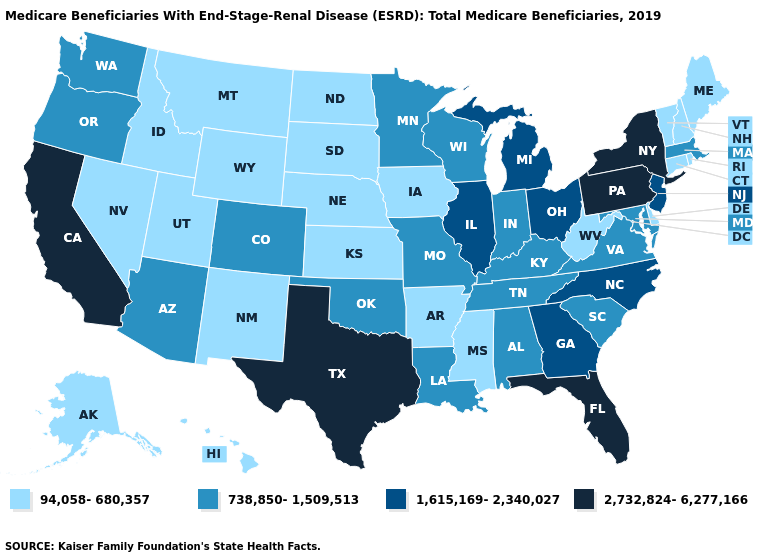Name the states that have a value in the range 94,058-680,357?
Answer briefly. Alaska, Arkansas, Connecticut, Delaware, Hawaii, Idaho, Iowa, Kansas, Maine, Mississippi, Montana, Nebraska, Nevada, New Hampshire, New Mexico, North Dakota, Rhode Island, South Dakota, Utah, Vermont, West Virginia, Wyoming. What is the value of Oklahoma?
Short answer required. 738,850-1,509,513. What is the value of Nebraska?
Answer briefly. 94,058-680,357. How many symbols are there in the legend?
Short answer required. 4. Name the states that have a value in the range 2,732,824-6,277,166?
Quick response, please. California, Florida, New York, Pennsylvania, Texas. Name the states that have a value in the range 94,058-680,357?
Write a very short answer. Alaska, Arkansas, Connecticut, Delaware, Hawaii, Idaho, Iowa, Kansas, Maine, Mississippi, Montana, Nebraska, Nevada, New Hampshire, New Mexico, North Dakota, Rhode Island, South Dakota, Utah, Vermont, West Virginia, Wyoming. Name the states that have a value in the range 1,615,169-2,340,027?
Concise answer only. Georgia, Illinois, Michigan, New Jersey, North Carolina, Ohio. Does Wisconsin have the same value as Alabama?
Quick response, please. Yes. Does the first symbol in the legend represent the smallest category?
Quick response, please. Yes. What is the highest value in the West ?
Be succinct. 2,732,824-6,277,166. What is the value of Wyoming?
Concise answer only. 94,058-680,357. What is the highest value in states that border Nevada?
Keep it brief. 2,732,824-6,277,166. Which states hav the highest value in the South?
Quick response, please. Florida, Texas. Name the states that have a value in the range 738,850-1,509,513?
Give a very brief answer. Alabama, Arizona, Colorado, Indiana, Kentucky, Louisiana, Maryland, Massachusetts, Minnesota, Missouri, Oklahoma, Oregon, South Carolina, Tennessee, Virginia, Washington, Wisconsin. What is the value of Massachusetts?
Answer briefly. 738,850-1,509,513. 